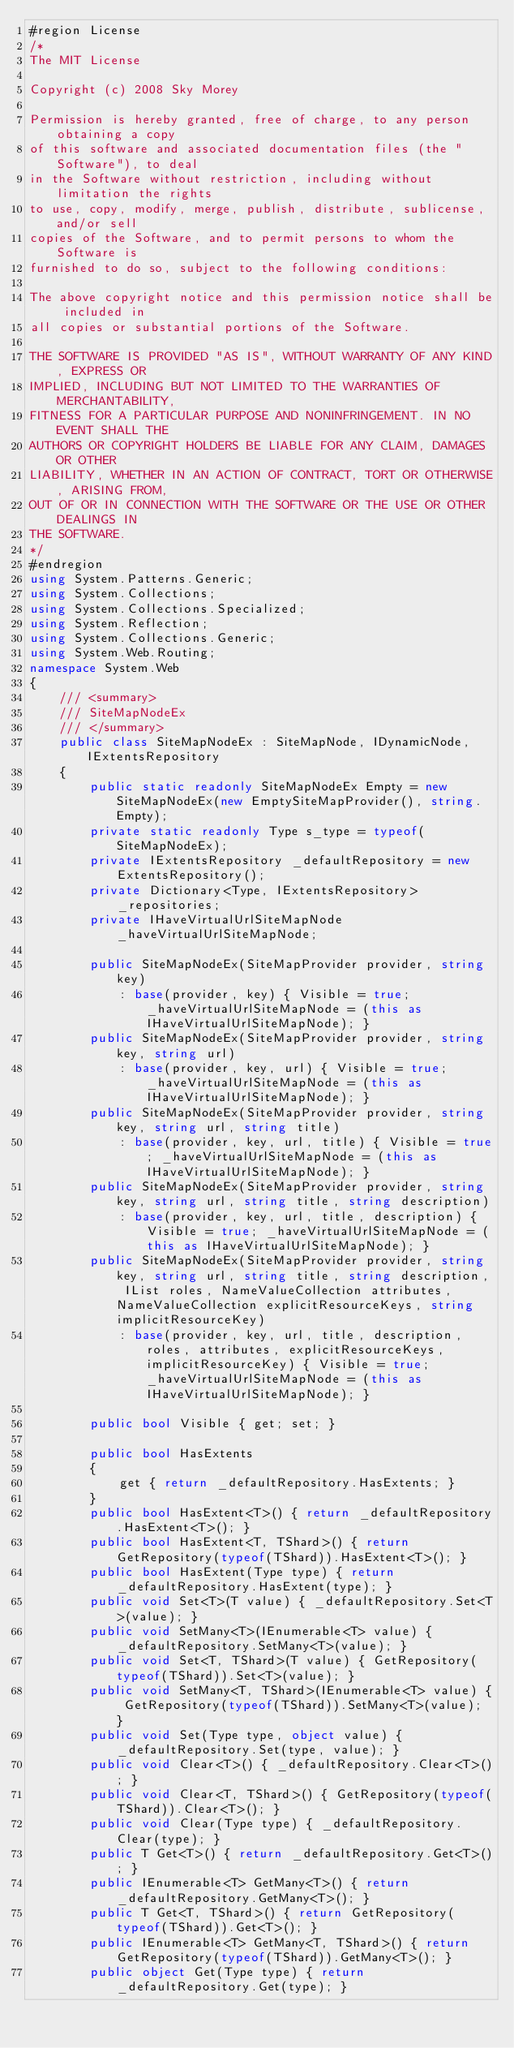Convert code to text. <code><loc_0><loc_0><loc_500><loc_500><_C#_>#region License
/*
The MIT License

Copyright (c) 2008 Sky Morey

Permission is hereby granted, free of charge, to any person obtaining a copy
of this software and associated documentation files (the "Software"), to deal
in the Software without restriction, including without limitation the rights
to use, copy, modify, merge, publish, distribute, sublicense, and/or sell
copies of the Software, and to permit persons to whom the Software is
furnished to do so, subject to the following conditions:

The above copyright notice and this permission notice shall be included in
all copies or substantial portions of the Software.

THE SOFTWARE IS PROVIDED "AS IS", WITHOUT WARRANTY OF ANY KIND, EXPRESS OR
IMPLIED, INCLUDING BUT NOT LIMITED TO THE WARRANTIES OF MERCHANTABILITY,
FITNESS FOR A PARTICULAR PURPOSE AND NONINFRINGEMENT. IN NO EVENT SHALL THE
AUTHORS OR COPYRIGHT HOLDERS BE LIABLE FOR ANY CLAIM, DAMAGES OR OTHER
LIABILITY, WHETHER IN AN ACTION OF CONTRACT, TORT OR OTHERWISE, ARISING FROM,
OUT OF OR IN CONNECTION WITH THE SOFTWARE OR THE USE OR OTHER DEALINGS IN
THE SOFTWARE.
*/
#endregion
using System.Patterns.Generic;
using System.Collections;
using System.Collections.Specialized;
using System.Reflection;
using System.Collections.Generic;
using System.Web.Routing;
namespace System.Web
{
    /// <summary>
    /// SiteMapNodeEx
    /// </summary>
    public class SiteMapNodeEx : SiteMapNode, IDynamicNode, IExtentsRepository
    {
        public static readonly SiteMapNodeEx Empty = new SiteMapNodeEx(new EmptySiteMapProvider(), string.Empty);
        private static readonly Type s_type = typeof(SiteMapNodeEx);
        private IExtentsRepository _defaultRepository = new ExtentsRepository();
        private Dictionary<Type, IExtentsRepository> _repositories;
        private IHaveVirtualUrlSiteMapNode _haveVirtualUrlSiteMapNode;

        public SiteMapNodeEx(SiteMapProvider provider, string key)
            : base(provider, key) { Visible = true; _haveVirtualUrlSiteMapNode = (this as IHaveVirtualUrlSiteMapNode); }
        public SiteMapNodeEx(SiteMapProvider provider, string key, string url)
            : base(provider, key, url) { Visible = true; _haveVirtualUrlSiteMapNode = (this as IHaveVirtualUrlSiteMapNode); }
        public SiteMapNodeEx(SiteMapProvider provider, string key, string url, string title)
            : base(provider, key, url, title) { Visible = true; _haveVirtualUrlSiteMapNode = (this as IHaveVirtualUrlSiteMapNode); }
        public SiteMapNodeEx(SiteMapProvider provider, string key, string url, string title, string description)
            : base(provider, key, url, title, description) { Visible = true; _haveVirtualUrlSiteMapNode = (this as IHaveVirtualUrlSiteMapNode); }
        public SiteMapNodeEx(SiteMapProvider provider, string key, string url, string title, string description, IList roles, NameValueCollection attributes, NameValueCollection explicitResourceKeys, string implicitResourceKey)
            : base(provider, key, url, title, description, roles, attributes, explicitResourceKeys, implicitResourceKey) { Visible = true; _haveVirtualUrlSiteMapNode = (this as IHaveVirtualUrlSiteMapNode); }

        public bool Visible { get; set; }

        public bool HasExtents
        {
            get { return _defaultRepository.HasExtents; }
        }
        public bool HasExtent<T>() { return _defaultRepository.HasExtent<T>(); }
        public bool HasExtent<T, TShard>() { return GetRepository(typeof(TShard)).HasExtent<T>(); }
        public bool HasExtent(Type type) { return _defaultRepository.HasExtent(type); }
        public void Set<T>(T value) { _defaultRepository.Set<T>(value); }
        public void SetMany<T>(IEnumerable<T> value) { _defaultRepository.SetMany<T>(value); }
        public void Set<T, TShard>(T value) { GetRepository(typeof(TShard)).Set<T>(value); }
        public void SetMany<T, TShard>(IEnumerable<T> value) { GetRepository(typeof(TShard)).SetMany<T>(value); }
        public void Set(Type type, object value) { _defaultRepository.Set(type, value); }
        public void Clear<T>() { _defaultRepository.Clear<T>(); }
        public void Clear<T, TShard>() { GetRepository(typeof(TShard)).Clear<T>(); }
        public void Clear(Type type) { _defaultRepository.Clear(type); }
        public T Get<T>() { return _defaultRepository.Get<T>(); }
        public IEnumerable<T> GetMany<T>() { return _defaultRepository.GetMany<T>(); }
        public T Get<T, TShard>() { return GetRepository(typeof(TShard)).Get<T>(); }
        public IEnumerable<T> GetMany<T, TShard>() { return GetRepository(typeof(TShard)).GetMany<T>(); }
        public object Get(Type type) { return _defaultRepository.Get(type); }</code> 